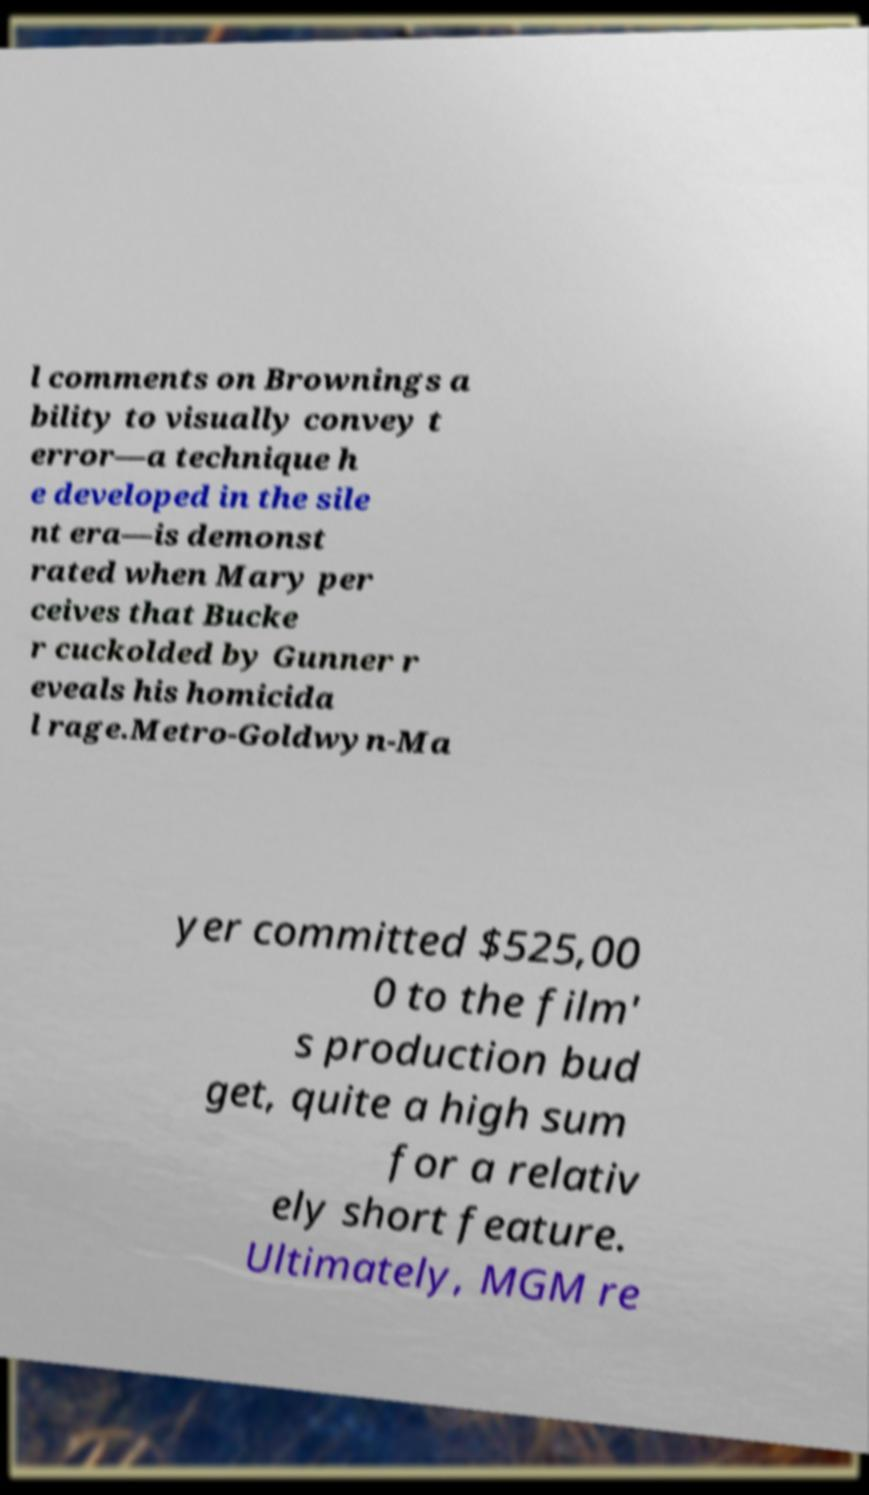Could you assist in decoding the text presented in this image and type it out clearly? l comments on Brownings a bility to visually convey t error—a technique h e developed in the sile nt era—is demonst rated when Mary per ceives that Bucke r cuckolded by Gunner r eveals his homicida l rage.Metro-Goldwyn-Ma yer committed $525,00 0 to the film' s production bud get, quite a high sum for a relativ ely short feature. Ultimately, MGM re 